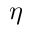<formula> <loc_0><loc_0><loc_500><loc_500>\eta</formula> 